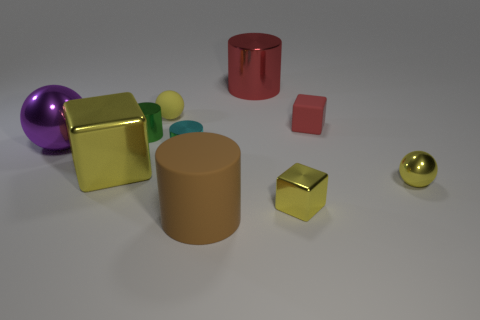How many other objects are there of the same color as the tiny rubber cube? Including the tiny rubber cube, there are two objects with a similar shade of pink. Beside the tiny cube, there's one other slightly larger cube that shares its color. 